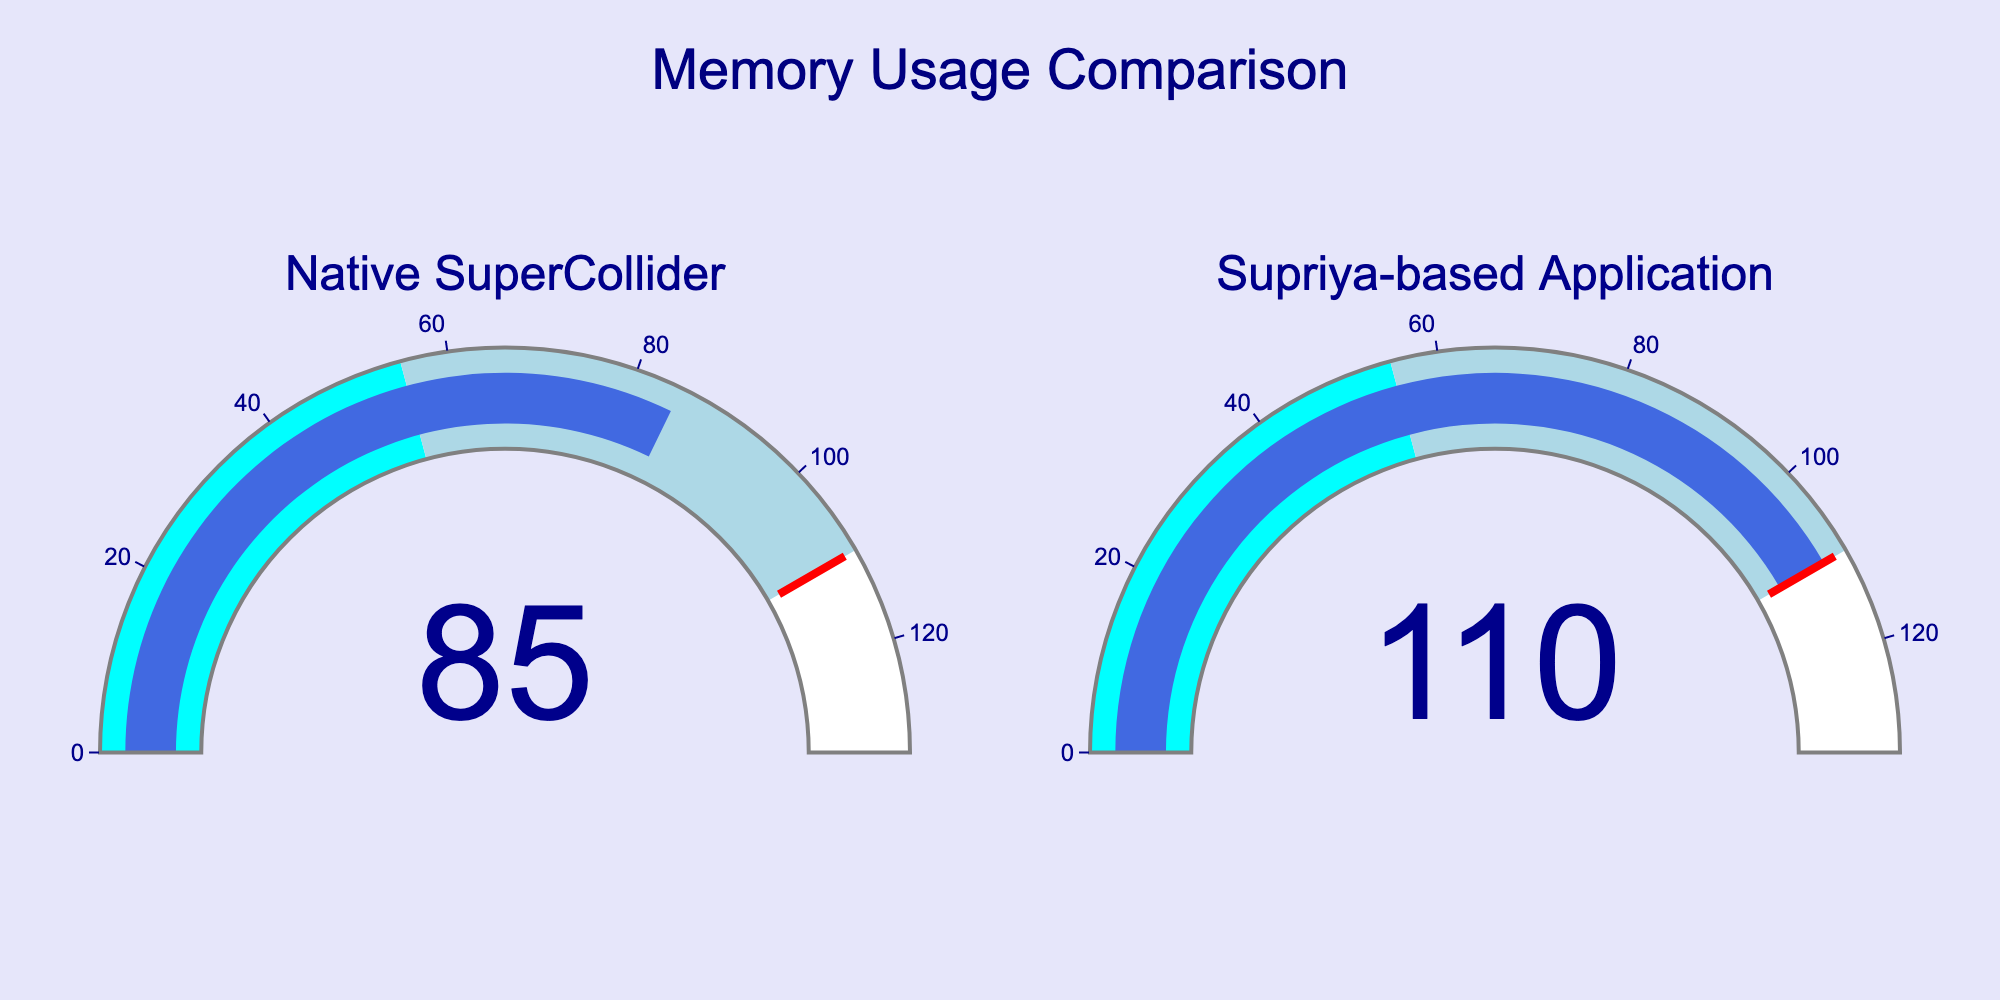What is the memory usage of the Native SuperCollider application? The gauge for the Native SuperCollider application shows a value of 85 MB.
Answer: 85 MB What is the maximum memory usage displayed on the gauges? The maximum value on the gauges is 110 MB, which corresponds to the Supriya-based application.
Answer: 110 MB How much more memory does the Supriya-based application use compared to the Native SuperCollider application? The Supriya-based application uses 110 MB, and the Native SuperCollider uses 85 MB. The difference is 110 MB - 85 MB = 25 MB.
Answer: 25 MB Which application uses more memory? Comparing the gauges, the Supriya-based application has a higher memory usage (110 MB) than the Native SuperCollider application (85 MB).
Answer: Supriya-based application What is the title of the figure? The title of the figure is located at the top center and reads 'Memory Usage Comparison'.
Answer: Memory Usage Comparison What is the color of the bar indicating the memory usage? The color of the bar indicating the memory usage on both gauges is royal blue.
Answer: Royal blue What is the range of the gauge axis? The axis range for both gauges extends up to 1.2 times the maximum memory usage value. Since the maximum value is 110 MB, the range is 0 to 132 MB.
Answer: 0 to 132 MB Which application’s memory usage reaches the highest threshold level indicated by the red line? The red threshold line, positioned at the maximum value, is reached by the Supriya-based application.
Answer: Supriya-based application Describe the color coding for the gauge. The gauge background has two color zones: cyan from 0 to 50% of the max value, and light blue from 50% to 100% of the max value.
Answer: Cyan and light blue What is the background color of the whole figure? The background color of the entire figure is lavender.
Answer: Lavender 